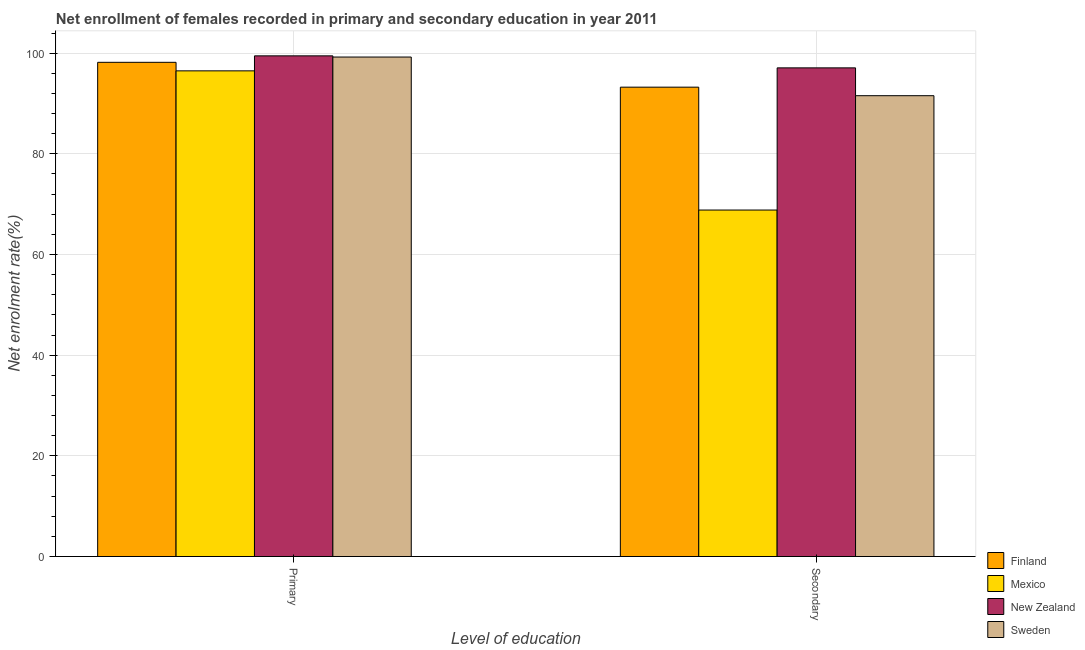How many different coloured bars are there?
Provide a succinct answer. 4. Are the number of bars on each tick of the X-axis equal?
Ensure brevity in your answer.  Yes. How many bars are there on the 1st tick from the right?
Give a very brief answer. 4. What is the label of the 2nd group of bars from the left?
Provide a succinct answer. Secondary. What is the enrollment rate in secondary education in Mexico?
Ensure brevity in your answer.  68.84. Across all countries, what is the maximum enrollment rate in primary education?
Ensure brevity in your answer.  99.47. Across all countries, what is the minimum enrollment rate in primary education?
Your response must be concise. 96.49. In which country was the enrollment rate in secondary education maximum?
Provide a short and direct response. New Zealand. What is the total enrollment rate in primary education in the graph?
Offer a very short reply. 393.37. What is the difference between the enrollment rate in secondary education in Sweden and that in New Zealand?
Ensure brevity in your answer.  -5.53. What is the difference between the enrollment rate in secondary education in Finland and the enrollment rate in primary education in Sweden?
Make the answer very short. -5.99. What is the average enrollment rate in secondary education per country?
Provide a short and direct response. 87.68. What is the difference between the enrollment rate in primary education and enrollment rate in secondary education in Sweden?
Your answer should be compact. 7.68. In how many countries, is the enrollment rate in secondary education greater than 48 %?
Your answer should be very brief. 4. What is the ratio of the enrollment rate in primary education in New Zealand to that in Mexico?
Make the answer very short. 1.03. Is the enrollment rate in secondary education in Mexico less than that in Finland?
Provide a short and direct response. Yes. What does the 1st bar from the left in Secondary represents?
Keep it short and to the point. Finland. Are all the bars in the graph horizontal?
Ensure brevity in your answer.  No. What is the difference between two consecutive major ticks on the Y-axis?
Offer a very short reply. 20. Does the graph contain grids?
Give a very brief answer. Yes. Where does the legend appear in the graph?
Make the answer very short. Bottom right. How many legend labels are there?
Ensure brevity in your answer.  4. How are the legend labels stacked?
Make the answer very short. Vertical. What is the title of the graph?
Offer a terse response. Net enrollment of females recorded in primary and secondary education in year 2011. Does "Sao Tome and Principe" appear as one of the legend labels in the graph?
Give a very brief answer. No. What is the label or title of the X-axis?
Give a very brief answer. Level of education. What is the label or title of the Y-axis?
Keep it short and to the point. Net enrolment rate(%). What is the Net enrolment rate(%) of Finland in Primary?
Keep it short and to the point. 98.18. What is the Net enrolment rate(%) in Mexico in Primary?
Provide a succinct answer. 96.49. What is the Net enrolment rate(%) of New Zealand in Primary?
Ensure brevity in your answer.  99.47. What is the Net enrolment rate(%) in Sweden in Primary?
Offer a terse response. 99.23. What is the Net enrolment rate(%) of Finland in Secondary?
Keep it short and to the point. 93.25. What is the Net enrolment rate(%) in Mexico in Secondary?
Ensure brevity in your answer.  68.84. What is the Net enrolment rate(%) in New Zealand in Secondary?
Ensure brevity in your answer.  97.08. What is the Net enrolment rate(%) of Sweden in Secondary?
Your answer should be compact. 91.55. Across all Level of education, what is the maximum Net enrolment rate(%) in Finland?
Make the answer very short. 98.18. Across all Level of education, what is the maximum Net enrolment rate(%) in Mexico?
Provide a succinct answer. 96.49. Across all Level of education, what is the maximum Net enrolment rate(%) of New Zealand?
Make the answer very short. 99.47. Across all Level of education, what is the maximum Net enrolment rate(%) in Sweden?
Your answer should be very brief. 99.23. Across all Level of education, what is the minimum Net enrolment rate(%) in Finland?
Your response must be concise. 93.25. Across all Level of education, what is the minimum Net enrolment rate(%) of Mexico?
Keep it short and to the point. 68.84. Across all Level of education, what is the minimum Net enrolment rate(%) in New Zealand?
Provide a short and direct response. 97.08. Across all Level of education, what is the minimum Net enrolment rate(%) in Sweden?
Your answer should be compact. 91.55. What is the total Net enrolment rate(%) in Finland in the graph?
Keep it short and to the point. 191.43. What is the total Net enrolment rate(%) in Mexico in the graph?
Make the answer very short. 165.33. What is the total Net enrolment rate(%) in New Zealand in the graph?
Keep it short and to the point. 196.55. What is the total Net enrolment rate(%) in Sweden in the graph?
Ensure brevity in your answer.  190.78. What is the difference between the Net enrolment rate(%) of Finland in Primary and that in Secondary?
Make the answer very short. 4.94. What is the difference between the Net enrolment rate(%) in Mexico in Primary and that in Secondary?
Make the answer very short. 27.65. What is the difference between the Net enrolment rate(%) of New Zealand in Primary and that in Secondary?
Provide a succinct answer. 2.39. What is the difference between the Net enrolment rate(%) in Sweden in Primary and that in Secondary?
Provide a short and direct response. 7.68. What is the difference between the Net enrolment rate(%) in Finland in Primary and the Net enrolment rate(%) in Mexico in Secondary?
Your response must be concise. 29.34. What is the difference between the Net enrolment rate(%) of Finland in Primary and the Net enrolment rate(%) of New Zealand in Secondary?
Your answer should be very brief. 1.1. What is the difference between the Net enrolment rate(%) in Finland in Primary and the Net enrolment rate(%) in Sweden in Secondary?
Offer a very short reply. 6.63. What is the difference between the Net enrolment rate(%) of Mexico in Primary and the Net enrolment rate(%) of New Zealand in Secondary?
Your response must be concise. -0.59. What is the difference between the Net enrolment rate(%) of Mexico in Primary and the Net enrolment rate(%) of Sweden in Secondary?
Give a very brief answer. 4.94. What is the difference between the Net enrolment rate(%) in New Zealand in Primary and the Net enrolment rate(%) in Sweden in Secondary?
Offer a very short reply. 7.91. What is the average Net enrolment rate(%) of Finland per Level of education?
Provide a succinct answer. 95.71. What is the average Net enrolment rate(%) of Mexico per Level of education?
Your response must be concise. 82.66. What is the average Net enrolment rate(%) of New Zealand per Level of education?
Give a very brief answer. 98.27. What is the average Net enrolment rate(%) of Sweden per Level of education?
Provide a succinct answer. 95.39. What is the difference between the Net enrolment rate(%) of Finland and Net enrolment rate(%) of Mexico in Primary?
Keep it short and to the point. 1.69. What is the difference between the Net enrolment rate(%) in Finland and Net enrolment rate(%) in New Zealand in Primary?
Your answer should be compact. -1.28. What is the difference between the Net enrolment rate(%) of Finland and Net enrolment rate(%) of Sweden in Primary?
Make the answer very short. -1.05. What is the difference between the Net enrolment rate(%) of Mexico and Net enrolment rate(%) of New Zealand in Primary?
Offer a terse response. -2.98. What is the difference between the Net enrolment rate(%) in Mexico and Net enrolment rate(%) in Sweden in Primary?
Your response must be concise. -2.74. What is the difference between the Net enrolment rate(%) of New Zealand and Net enrolment rate(%) of Sweden in Primary?
Your answer should be compact. 0.24. What is the difference between the Net enrolment rate(%) in Finland and Net enrolment rate(%) in Mexico in Secondary?
Provide a short and direct response. 24.41. What is the difference between the Net enrolment rate(%) in Finland and Net enrolment rate(%) in New Zealand in Secondary?
Your answer should be compact. -3.84. What is the difference between the Net enrolment rate(%) of Finland and Net enrolment rate(%) of Sweden in Secondary?
Provide a succinct answer. 1.69. What is the difference between the Net enrolment rate(%) in Mexico and Net enrolment rate(%) in New Zealand in Secondary?
Offer a very short reply. -28.24. What is the difference between the Net enrolment rate(%) of Mexico and Net enrolment rate(%) of Sweden in Secondary?
Keep it short and to the point. -22.72. What is the difference between the Net enrolment rate(%) of New Zealand and Net enrolment rate(%) of Sweden in Secondary?
Make the answer very short. 5.53. What is the ratio of the Net enrolment rate(%) in Finland in Primary to that in Secondary?
Give a very brief answer. 1.05. What is the ratio of the Net enrolment rate(%) in Mexico in Primary to that in Secondary?
Keep it short and to the point. 1.4. What is the ratio of the Net enrolment rate(%) of New Zealand in Primary to that in Secondary?
Offer a terse response. 1.02. What is the ratio of the Net enrolment rate(%) in Sweden in Primary to that in Secondary?
Keep it short and to the point. 1.08. What is the difference between the highest and the second highest Net enrolment rate(%) in Finland?
Keep it short and to the point. 4.94. What is the difference between the highest and the second highest Net enrolment rate(%) in Mexico?
Your answer should be very brief. 27.65. What is the difference between the highest and the second highest Net enrolment rate(%) of New Zealand?
Keep it short and to the point. 2.39. What is the difference between the highest and the second highest Net enrolment rate(%) in Sweden?
Provide a short and direct response. 7.68. What is the difference between the highest and the lowest Net enrolment rate(%) in Finland?
Your answer should be compact. 4.94. What is the difference between the highest and the lowest Net enrolment rate(%) in Mexico?
Offer a terse response. 27.65. What is the difference between the highest and the lowest Net enrolment rate(%) of New Zealand?
Keep it short and to the point. 2.39. What is the difference between the highest and the lowest Net enrolment rate(%) in Sweden?
Offer a terse response. 7.68. 